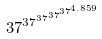<formula> <loc_0><loc_0><loc_500><loc_500>3 7 ^ { 3 7 ^ { 3 7 ^ { 3 7 ^ { 3 7 ^ { 4 . 8 5 9 } } } } }</formula> 